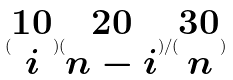Convert formula to latex. <formula><loc_0><loc_0><loc_500><loc_500>( \begin{matrix} 1 0 \\ i \end{matrix} ) ( \begin{matrix} 2 0 \\ n - i \end{matrix} ) / ( \begin{matrix} 3 0 \\ n \end{matrix} )</formula> 